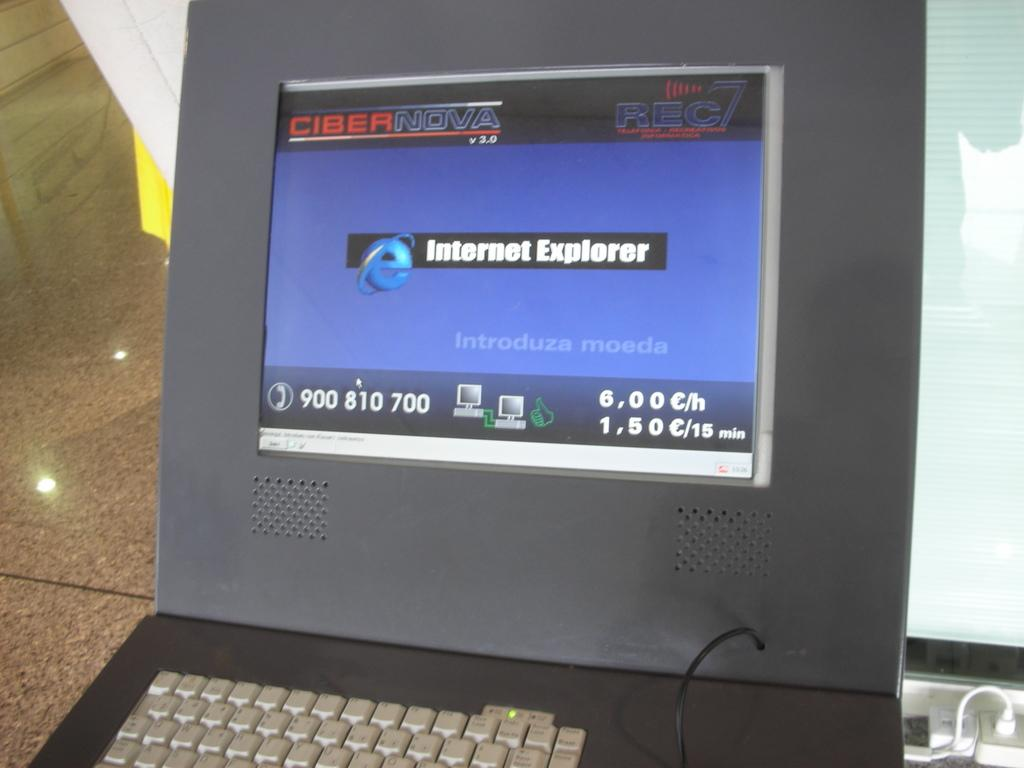<image>
Summarize the visual content of the image. a screen that is open to a page that says 'internet explorer' 